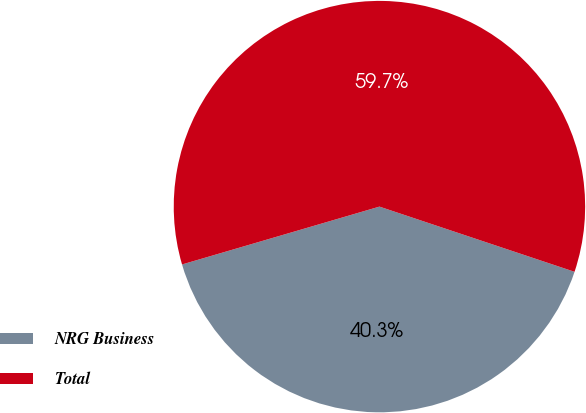Convert chart to OTSL. <chart><loc_0><loc_0><loc_500><loc_500><pie_chart><fcel>NRG Business<fcel>Total<nl><fcel>40.33%<fcel>59.67%<nl></chart> 